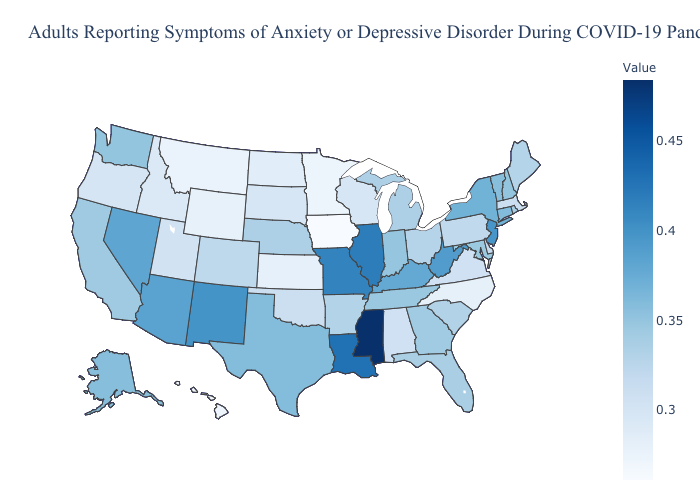Does Iowa have the lowest value in the USA?
Concise answer only. Yes. Which states have the highest value in the USA?
Answer briefly. Mississippi. Among the states that border Iowa , does Minnesota have the lowest value?
Concise answer only. Yes. Which states have the lowest value in the MidWest?
Concise answer only. Iowa. Among the states that border Delaware , does New Jersey have the highest value?
Concise answer only. Yes. Does Mississippi have the highest value in the USA?
Keep it brief. Yes. Which states have the lowest value in the USA?
Concise answer only. Iowa. Does Washington have a lower value than New Mexico?
Be succinct. Yes. 